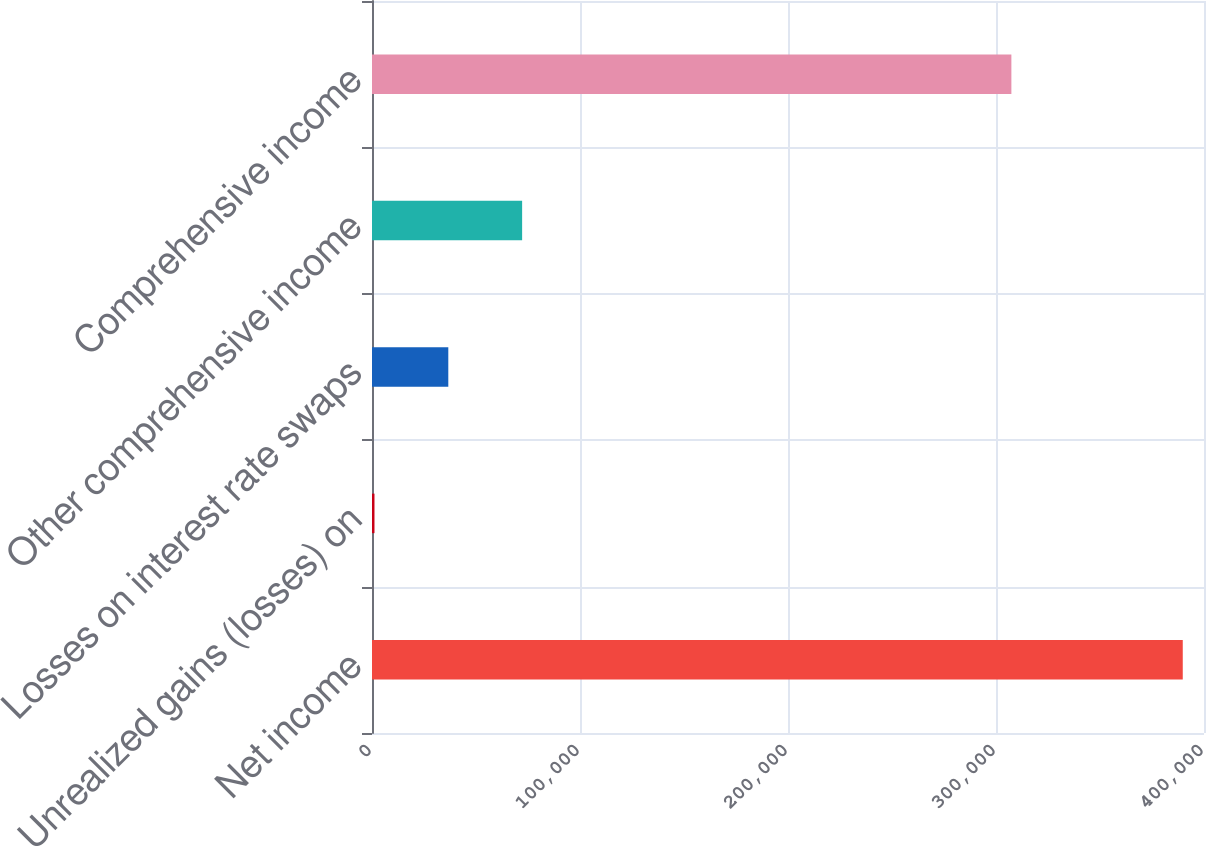<chart> <loc_0><loc_0><loc_500><loc_500><bar_chart><fcel>Net income<fcel>Unrealized gains (losses) on<fcel>Losses on interest rate swaps<fcel>Other comprehensive income<fcel>Comprehensive income<nl><fcel>389790<fcel>1192<fcel>36683.9<fcel>72175.8<fcel>307395<nl></chart> 